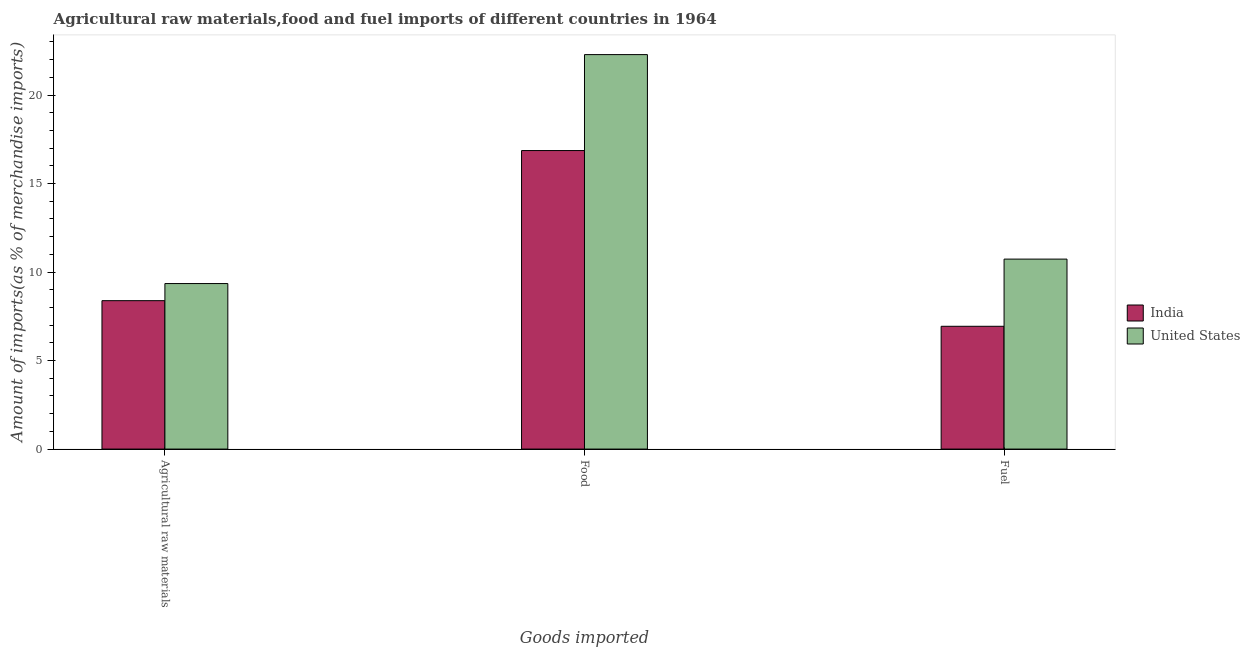How many different coloured bars are there?
Provide a succinct answer. 2. Are the number of bars per tick equal to the number of legend labels?
Keep it short and to the point. Yes. What is the label of the 1st group of bars from the left?
Keep it short and to the point. Agricultural raw materials. What is the percentage of raw materials imports in India?
Make the answer very short. 8.38. Across all countries, what is the maximum percentage of raw materials imports?
Provide a short and direct response. 9.35. Across all countries, what is the minimum percentage of food imports?
Your response must be concise. 16.86. In which country was the percentage of fuel imports minimum?
Offer a very short reply. India. What is the total percentage of fuel imports in the graph?
Your answer should be very brief. 17.67. What is the difference between the percentage of raw materials imports in United States and that in India?
Offer a terse response. 0.97. What is the difference between the percentage of fuel imports in United States and the percentage of raw materials imports in India?
Give a very brief answer. 2.35. What is the average percentage of raw materials imports per country?
Offer a terse response. 8.87. What is the difference between the percentage of food imports and percentage of fuel imports in United States?
Offer a terse response. 11.55. What is the ratio of the percentage of raw materials imports in India to that in United States?
Offer a terse response. 0.9. Is the percentage of raw materials imports in United States less than that in India?
Keep it short and to the point. No. Is the difference between the percentage of food imports in India and United States greater than the difference between the percentage of raw materials imports in India and United States?
Provide a short and direct response. No. What is the difference between the highest and the second highest percentage of fuel imports?
Provide a short and direct response. 3.8. What is the difference between the highest and the lowest percentage of fuel imports?
Your response must be concise. 3.8. What does the 1st bar from the right in Food represents?
Offer a terse response. United States. Is it the case that in every country, the sum of the percentage of raw materials imports and percentage of food imports is greater than the percentage of fuel imports?
Give a very brief answer. Yes. Are all the bars in the graph horizontal?
Your answer should be compact. No. Are the values on the major ticks of Y-axis written in scientific E-notation?
Make the answer very short. No. Does the graph contain any zero values?
Give a very brief answer. No. Where does the legend appear in the graph?
Make the answer very short. Center right. What is the title of the graph?
Make the answer very short. Agricultural raw materials,food and fuel imports of different countries in 1964. Does "Uruguay" appear as one of the legend labels in the graph?
Provide a succinct answer. No. What is the label or title of the X-axis?
Ensure brevity in your answer.  Goods imported. What is the label or title of the Y-axis?
Make the answer very short. Amount of imports(as % of merchandise imports). What is the Amount of imports(as % of merchandise imports) in India in Agricultural raw materials?
Your answer should be compact. 8.38. What is the Amount of imports(as % of merchandise imports) of United States in Agricultural raw materials?
Your answer should be very brief. 9.35. What is the Amount of imports(as % of merchandise imports) of India in Food?
Your answer should be compact. 16.86. What is the Amount of imports(as % of merchandise imports) of United States in Food?
Provide a succinct answer. 22.28. What is the Amount of imports(as % of merchandise imports) of India in Fuel?
Keep it short and to the point. 6.94. What is the Amount of imports(as % of merchandise imports) in United States in Fuel?
Offer a terse response. 10.73. Across all Goods imported, what is the maximum Amount of imports(as % of merchandise imports) of India?
Provide a succinct answer. 16.86. Across all Goods imported, what is the maximum Amount of imports(as % of merchandise imports) of United States?
Provide a succinct answer. 22.28. Across all Goods imported, what is the minimum Amount of imports(as % of merchandise imports) of India?
Provide a succinct answer. 6.94. Across all Goods imported, what is the minimum Amount of imports(as % of merchandise imports) of United States?
Your answer should be compact. 9.35. What is the total Amount of imports(as % of merchandise imports) of India in the graph?
Your answer should be compact. 32.18. What is the total Amount of imports(as % of merchandise imports) in United States in the graph?
Offer a terse response. 42.37. What is the difference between the Amount of imports(as % of merchandise imports) of India in Agricultural raw materials and that in Food?
Provide a short and direct response. -8.48. What is the difference between the Amount of imports(as % of merchandise imports) of United States in Agricultural raw materials and that in Food?
Your answer should be very brief. -12.93. What is the difference between the Amount of imports(as % of merchandise imports) of India in Agricultural raw materials and that in Fuel?
Give a very brief answer. 1.45. What is the difference between the Amount of imports(as % of merchandise imports) in United States in Agricultural raw materials and that in Fuel?
Offer a very short reply. -1.38. What is the difference between the Amount of imports(as % of merchandise imports) of India in Food and that in Fuel?
Provide a short and direct response. 9.93. What is the difference between the Amount of imports(as % of merchandise imports) of United States in Food and that in Fuel?
Your answer should be very brief. 11.55. What is the difference between the Amount of imports(as % of merchandise imports) of India in Agricultural raw materials and the Amount of imports(as % of merchandise imports) of United States in Food?
Offer a terse response. -13.9. What is the difference between the Amount of imports(as % of merchandise imports) in India in Agricultural raw materials and the Amount of imports(as % of merchandise imports) in United States in Fuel?
Your answer should be very brief. -2.35. What is the difference between the Amount of imports(as % of merchandise imports) in India in Food and the Amount of imports(as % of merchandise imports) in United States in Fuel?
Your response must be concise. 6.13. What is the average Amount of imports(as % of merchandise imports) in India per Goods imported?
Provide a succinct answer. 10.73. What is the average Amount of imports(as % of merchandise imports) in United States per Goods imported?
Keep it short and to the point. 14.12. What is the difference between the Amount of imports(as % of merchandise imports) in India and Amount of imports(as % of merchandise imports) in United States in Agricultural raw materials?
Make the answer very short. -0.97. What is the difference between the Amount of imports(as % of merchandise imports) of India and Amount of imports(as % of merchandise imports) of United States in Food?
Offer a terse response. -5.42. What is the difference between the Amount of imports(as % of merchandise imports) in India and Amount of imports(as % of merchandise imports) in United States in Fuel?
Your response must be concise. -3.8. What is the ratio of the Amount of imports(as % of merchandise imports) in India in Agricultural raw materials to that in Food?
Offer a terse response. 0.5. What is the ratio of the Amount of imports(as % of merchandise imports) of United States in Agricultural raw materials to that in Food?
Your response must be concise. 0.42. What is the ratio of the Amount of imports(as % of merchandise imports) of India in Agricultural raw materials to that in Fuel?
Provide a short and direct response. 1.21. What is the ratio of the Amount of imports(as % of merchandise imports) in United States in Agricultural raw materials to that in Fuel?
Provide a succinct answer. 0.87. What is the ratio of the Amount of imports(as % of merchandise imports) in India in Food to that in Fuel?
Offer a very short reply. 2.43. What is the ratio of the Amount of imports(as % of merchandise imports) of United States in Food to that in Fuel?
Keep it short and to the point. 2.08. What is the difference between the highest and the second highest Amount of imports(as % of merchandise imports) of India?
Your answer should be very brief. 8.48. What is the difference between the highest and the second highest Amount of imports(as % of merchandise imports) in United States?
Ensure brevity in your answer.  11.55. What is the difference between the highest and the lowest Amount of imports(as % of merchandise imports) in India?
Make the answer very short. 9.93. What is the difference between the highest and the lowest Amount of imports(as % of merchandise imports) in United States?
Offer a very short reply. 12.93. 